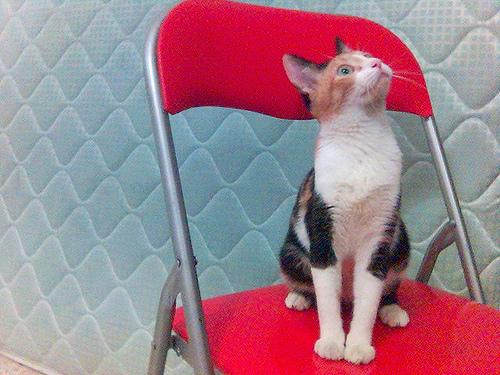What color is the chair the cat is sitting on?
Quick response, please. Red. What color are the cat's eyes?
Short answer required. Green. Does the chair fold?
Be succinct. Yes. 